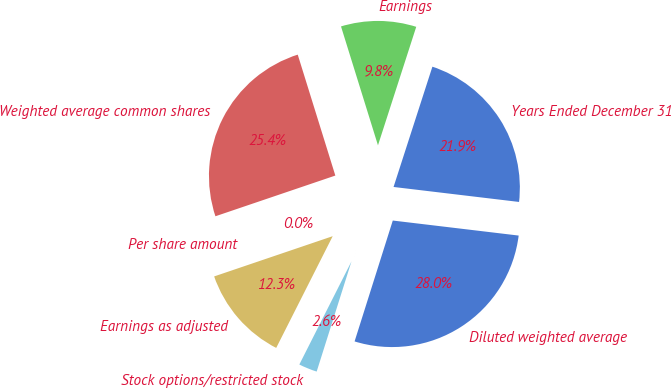Convert chart. <chart><loc_0><loc_0><loc_500><loc_500><pie_chart><fcel>Years Ended December 31<fcel>Earnings<fcel>Weighted average common shares<fcel>Per share amount<fcel>Earnings as adjusted<fcel>Stock options/restricted stock<fcel>Diluted weighted average<nl><fcel>21.92%<fcel>9.77%<fcel>25.41%<fcel>0.0%<fcel>12.34%<fcel>2.58%<fcel>27.98%<nl></chart> 